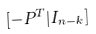<formula> <loc_0><loc_0><loc_500><loc_500>[ - P ^ { T } | I _ { n - k } ]</formula> 